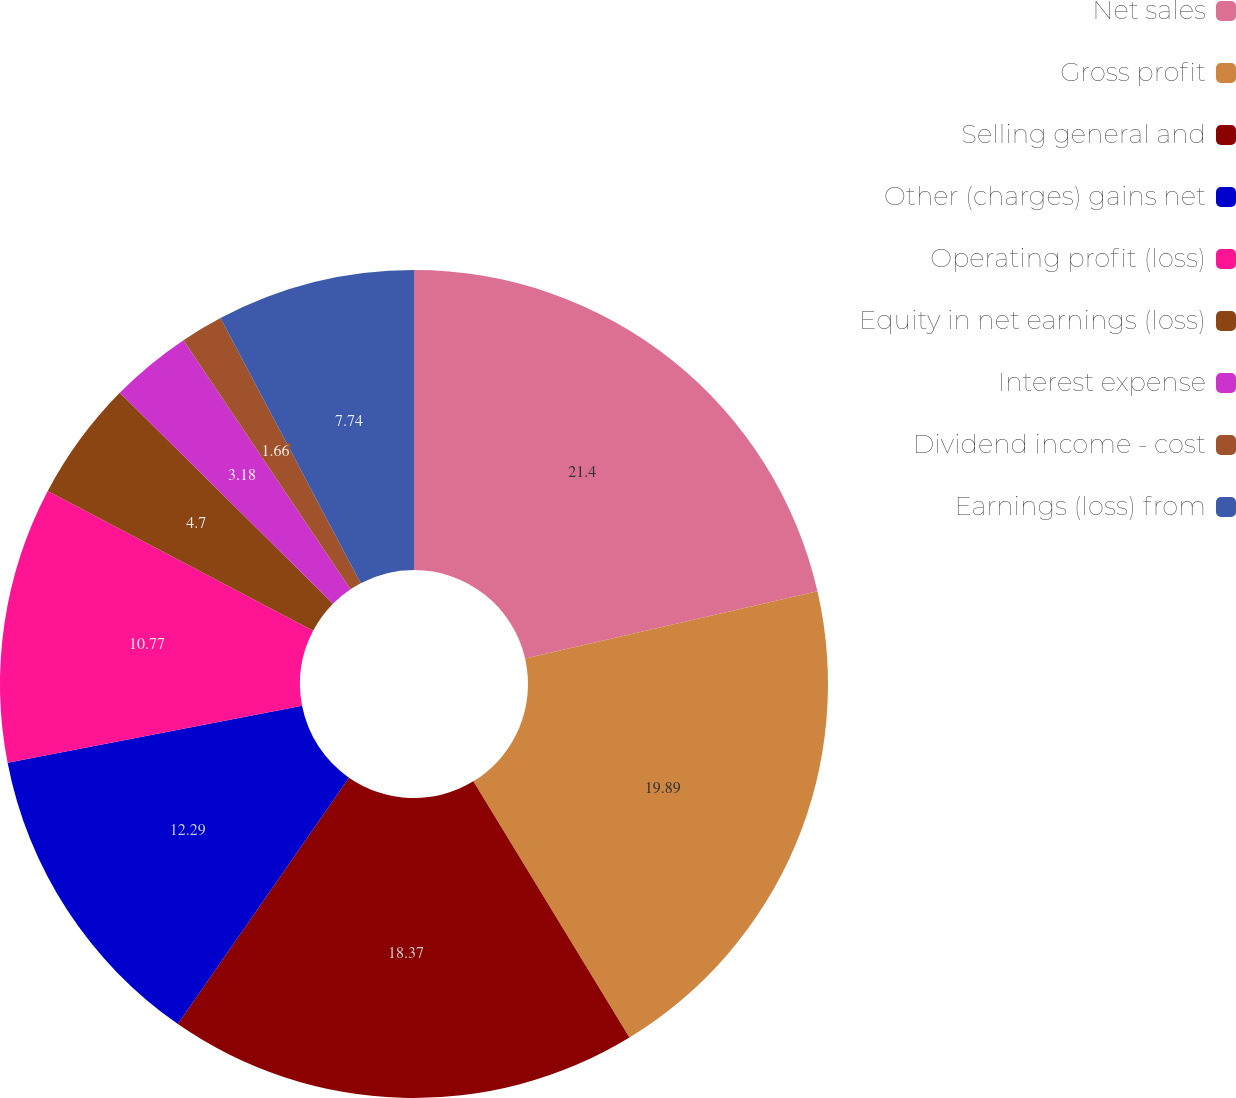Convert chart to OTSL. <chart><loc_0><loc_0><loc_500><loc_500><pie_chart><fcel>Net sales<fcel>Gross profit<fcel>Selling general and<fcel>Other (charges) gains net<fcel>Operating profit (loss)<fcel>Equity in net earnings (loss)<fcel>Interest expense<fcel>Dividend income - cost<fcel>Earnings (loss) from<nl><fcel>21.4%<fcel>19.89%<fcel>18.37%<fcel>12.29%<fcel>10.77%<fcel>4.7%<fcel>3.18%<fcel>1.66%<fcel>7.74%<nl></chart> 